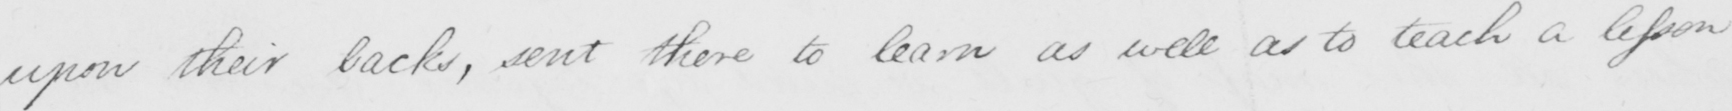Can you read and transcribe this handwriting? upon their backs , sent there to learn as well as to teach a lesson 